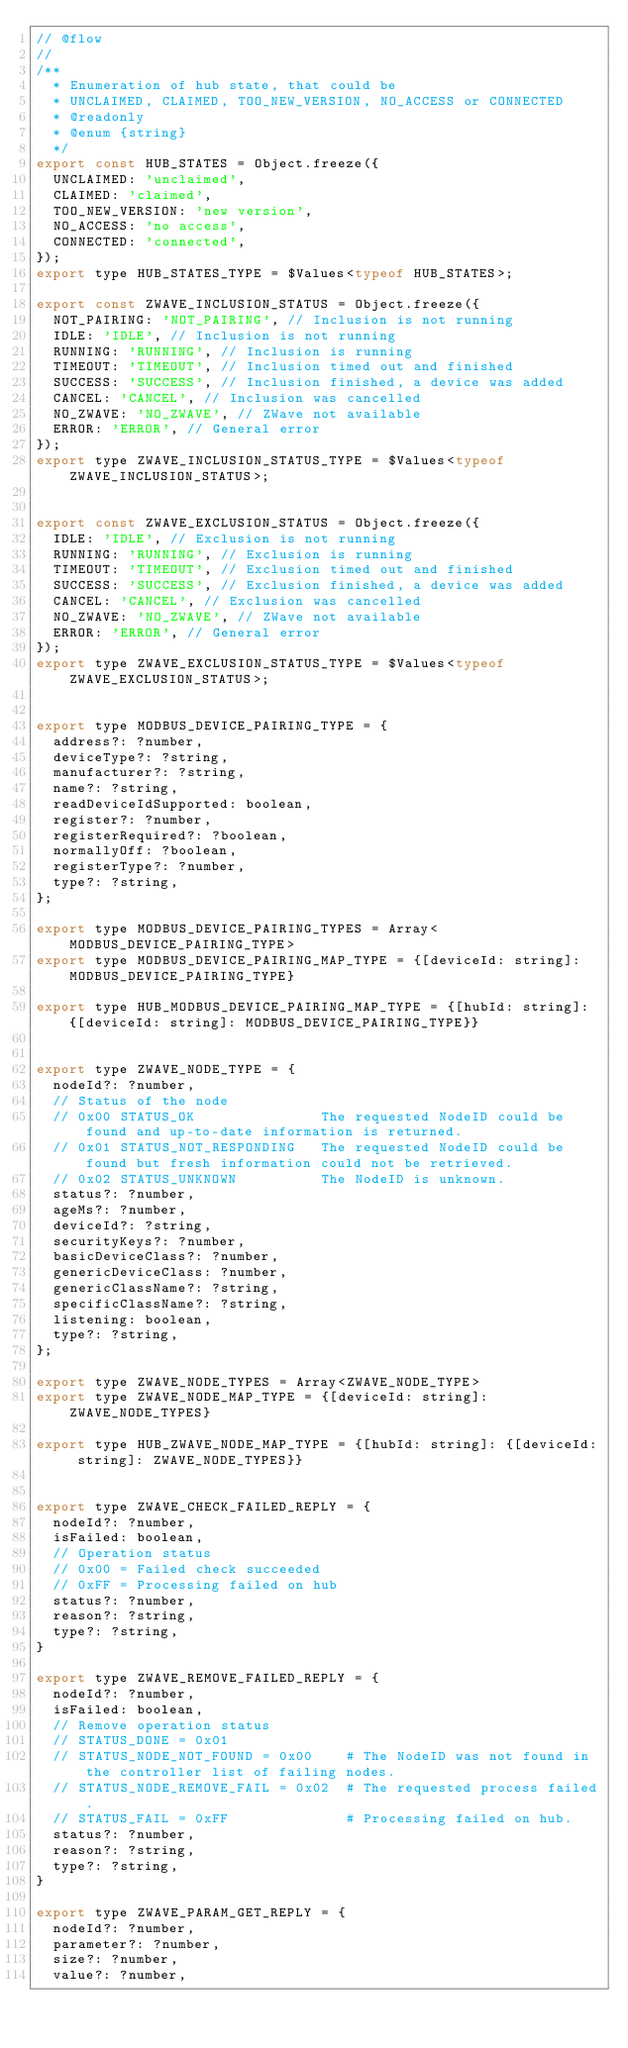Convert code to text. <code><loc_0><loc_0><loc_500><loc_500><_JavaScript_>// @flow
//
/**
  * Enumeration of hub state, that could be
  * UNCLAIMED, CLAIMED, TOO_NEW_VERSION, NO_ACCESS or CONNECTED
  * @readonly
  * @enum {string}
  */
export const HUB_STATES = Object.freeze({
  UNCLAIMED: 'unclaimed',
  CLAIMED: 'claimed',
  TOO_NEW_VERSION: 'new version',
  NO_ACCESS: 'no access',
  CONNECTED: 'connected',
});
export type HUB_STATES_TYPE = $Values<typeof HUB_STATES>;

export const ZWAVE_INCLUSION_STATUS = Object.freeze({
  NOT_PAIRING: 'NOT_PAIRING', // Inclusion is not running
  IDLE: 'IDLE', // Inclusion is not running
  RUNNING: 'RUNNING', // Inclusion is running
  TIMEOUT: 'TIMEOUT', // Inclusion timed out and finished
  SUCCESS: 'SUCCESS', // Inclusion finished, a device was added
  CANCEL: 'CANCEL', // Inclusion was cancelled
  NO_ZWAVE: 'NO_ZWAVE', // ZWave not available
  ERROR: 'ERROR', // General error
});
export type ZWAVE_INCLUSION_STATUS_TYPE = $Values<typeof ZWAVE_INCLUSION_STATUS>;


export const ZWAVE_EXCLUSION_STATUS = Object.freeze({
  IDLE: 'IDLE', // Exclusion is not running
  RUNNING: 'RUNNING', // Exclusion is running
  TIMEOUT: 'TIMEOUT', // Exclusion timed out and finished
  SUCCESS: 'SUCCESS', // Exclusion finished, a device was added
  CANCEL: 'CANCEL', // Exclusion was cancelled
  NO_ZWAVE: 'NO_ZWAVE', // ZWave not available
  ERROR: 'ERROR', // General error
});
export type ZWAVE_EXCLUSION_STATUS_TYPE = $Values<typeof ZWAVE_EXCLUSION_STATUS>;


export type MODBUS_DEVICE_PAIRING_TYPE = {
  address?: ?number,
  deviceType?: ?string,
  manufacturer?: ?string,
  name?: ?string,
  readDeviceIdSupported: boolean,
  register?: ?number,
  registerRequired?: ?boolean,
  normallyOff: ?boolean,
  registerType?: ?number,
  type?: ?string,
};

export type MODBUS_DEVICE_PAIRING_TYPES = Array<MODBUS_DEVICE_PAIRING_TYPE>
export type MODBUS_DEVICE_PAIRING_MAP_TYPE = {[deviceId: string]: MODBUS_DEVICE_PAIRING_TYPE}

export type HUB_MODBUS_DEVICE_PAIRING_MAP_TYPE = {[hubId: string]: {[deviceId: string]: MODBUS_DEVICE_PAIRING_TYPE}}


export type ZWAVE_NODE_TYPE = {
  nodeId?: ?number,
  // Status of the node
  // 0x00 STATUS_OK               The requested NodeID could be found and up-to-date information is returned.
  // 0x01 STATUS_NOT_RESPONDING   The requested NodeID could be found but fresh information could not be retrieved.
  // 0x02 STATUS_UNKNOWN          The NodeID is unknown.
  status?: ?number,
  ageMs?: ?number,
  deviceId?: ?string,
  securityKeys?: ?number,
  basicDeviceClass?: ?number,
  genericDeviceClass: ?number,
  genericClassName?: ?string,
  specificClassName?: ?string,
  listening: boolean,
  type?: ?string,
};

export type ZWAVE_NODE_TYPES = Array<ZWAVE_NODE_TYPE>
export type ZWAVE_NODE_MAP_TYPE = {[deviceId: string]: ZWAVE_NODE_TYPES}

export type HUB_ZWAVE_NODE_MAP_TYPE = {[hubId: string]: {[deviceId: string]: ZWAVE_NODE_TYPES}}


export type ZWAVE_CHECK_FAILED_REPLY = {
  nodeId?: ?number,
  isFailed: boolean,
  // Operation status
  // 0x00 = Failed check succeeded
  // 0xFF = Processing failed on hub
  status?: ?number,
  reason?: ?string,
  type?: ?string,
}

export type ZWAVE_REMOVE_FAILED_REPLY = {
  nodeId?: ?number,
  isFailed: boolean,
  // Remove operation status
  // STATUS_DONE = 0x01
  // STATUS_NODE_NOT_FOUND = 0x00    # The NodeID was not found in the controller list of failing nodes.
  // STATUS_NODE_REMOVE_FAIL = 0x02  # The requested process failed.
  // STATUS_FAIL = 0xFF              # Processing failed on hub.
  status?: ?number,
  reason?: ?string,
  type?: ?string,
}

export type ZWAVE_PARAM_GET_REPLY = {
  nodeId?: ?number,
  parameter?: ?number,
  size?: ?number,
  value?: ?number,</code> 